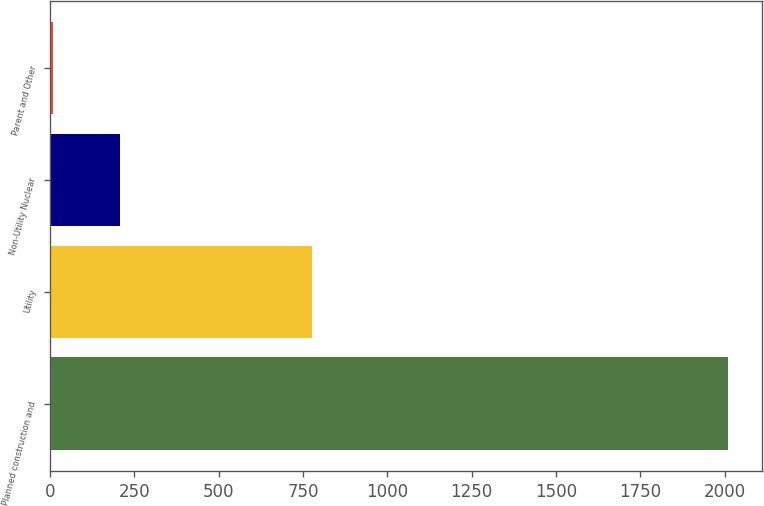<chart> <loc_0><loc_0><loc_500><loc_500><bar_chart><fcel>Planned construction and<fcel>Utility<fcel>Non-Utility Nuclear<fcel>Parent and Other<nl><fcel>2010<fcel>776<fcel>209.1<fcel>9<nl></chart> 